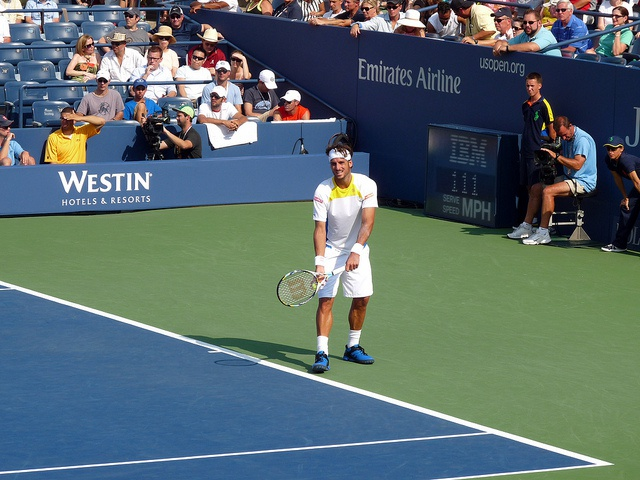Describe the objects in this image and their specific colors. I can see people in white, black, navy, and gray tones, people in white, olive, darkgray, and salmon tones, people in white, black, maroon, and lightblue tones, people in white, black, maroon, and brown tones, and people in white, black, navy, maroon, and brown tones in this image. 